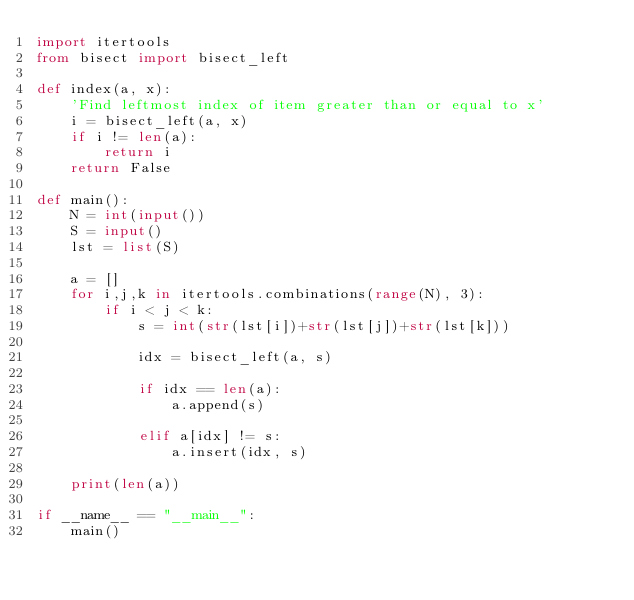Convert code to text. <code><loc_0><loc_0><loc_500><loc_500><_Python_>import itertools
from bisect import bisect_left

def index(a, x):
    'Find leftmost index of item greater than or equal to x'
    i = bisect_left(a, x)
    if i != len(a):
        return i
    return False

def main():
    N = int(input())
    S = input()
    lst = list(S)

    a = []
    for i,j,k in itertools.combinations(range(N), 3):
        if i < j < k:
            s = int(str(lst[i])+str(lst[j])+str(lst[k]))

            idx = bisect_left(a, s)

            if idx == len(a):
                a.append(s)
            
            elif a[idx] != s:
                a.insert(idx, s)

    print(len(a))

if __name__ == "__main__":
    main()
</code> 